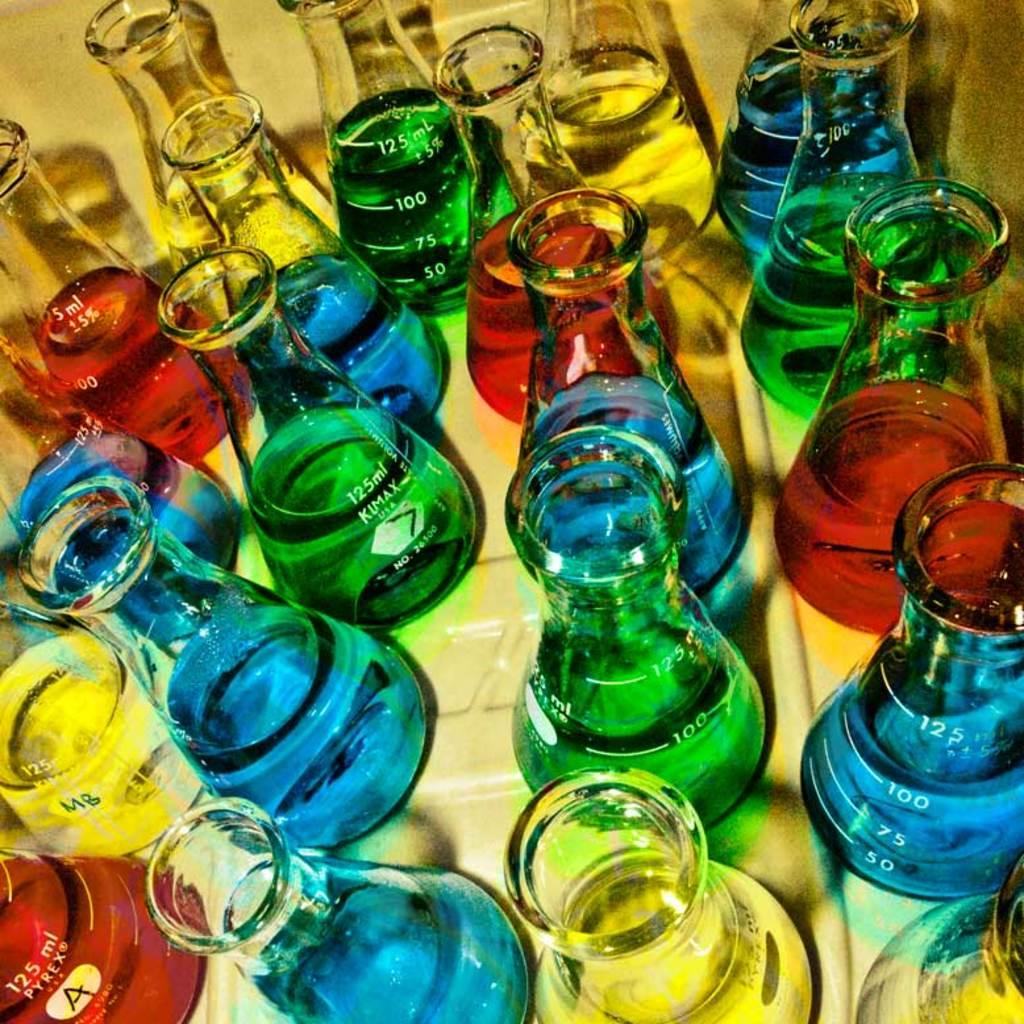<image>
Relay a brief, clear account of the picture shown. Blue, green, yellow and red liquids sit it jars, the red one to the bottom of the screen says pyrex A on it. 